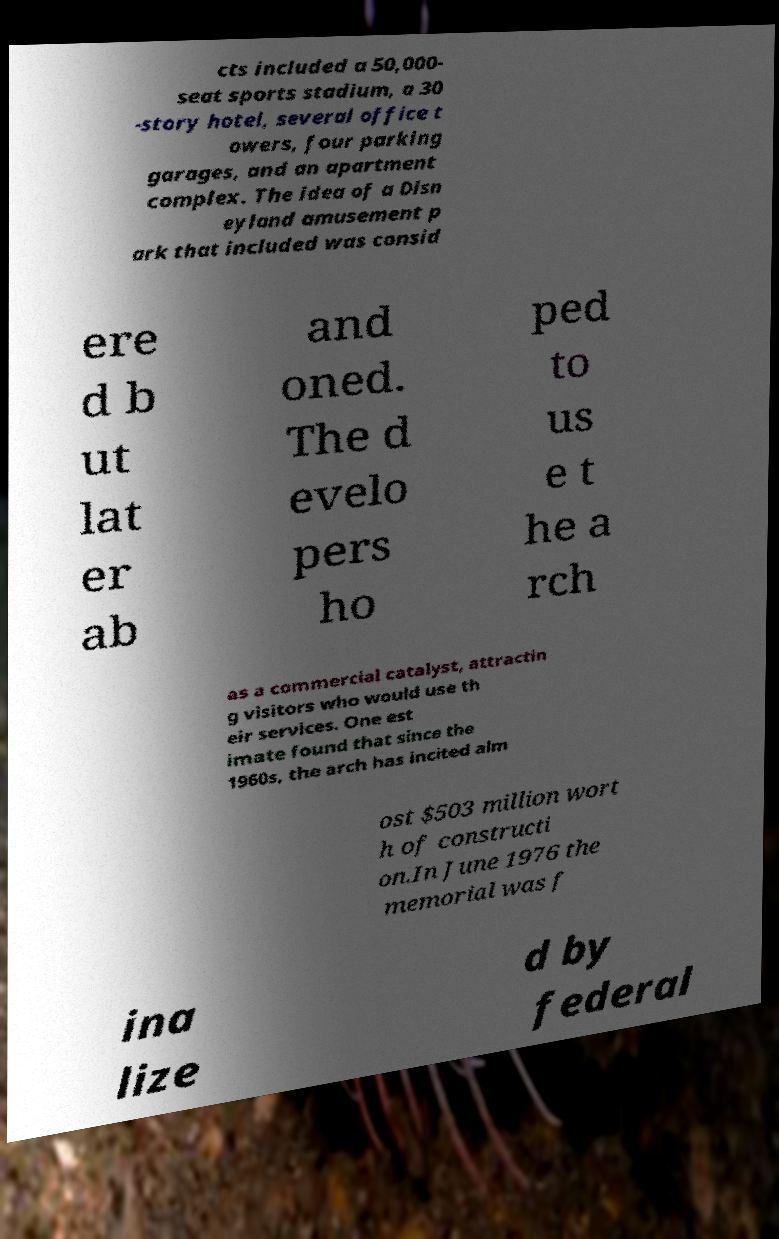Please read and relay the text visible in this image. What does it say? cts included a 50,000- seat sports stadium, a 30 -story hotel, several office t owers, four parking garages, and an apartment complex. The idea of a Disn eyland amusement p ark that included was consid ere d b ut lat er ab and oned. The d evelo pers ho ped to us e t he a rch as a commercial catalyst, attractin g visitors who would use th eir services. One est imate found that since the 1960s, the arch has incited alm ost $503 million wort h of constructi on.In June 1976 the memorial was f ina lize d by federal 